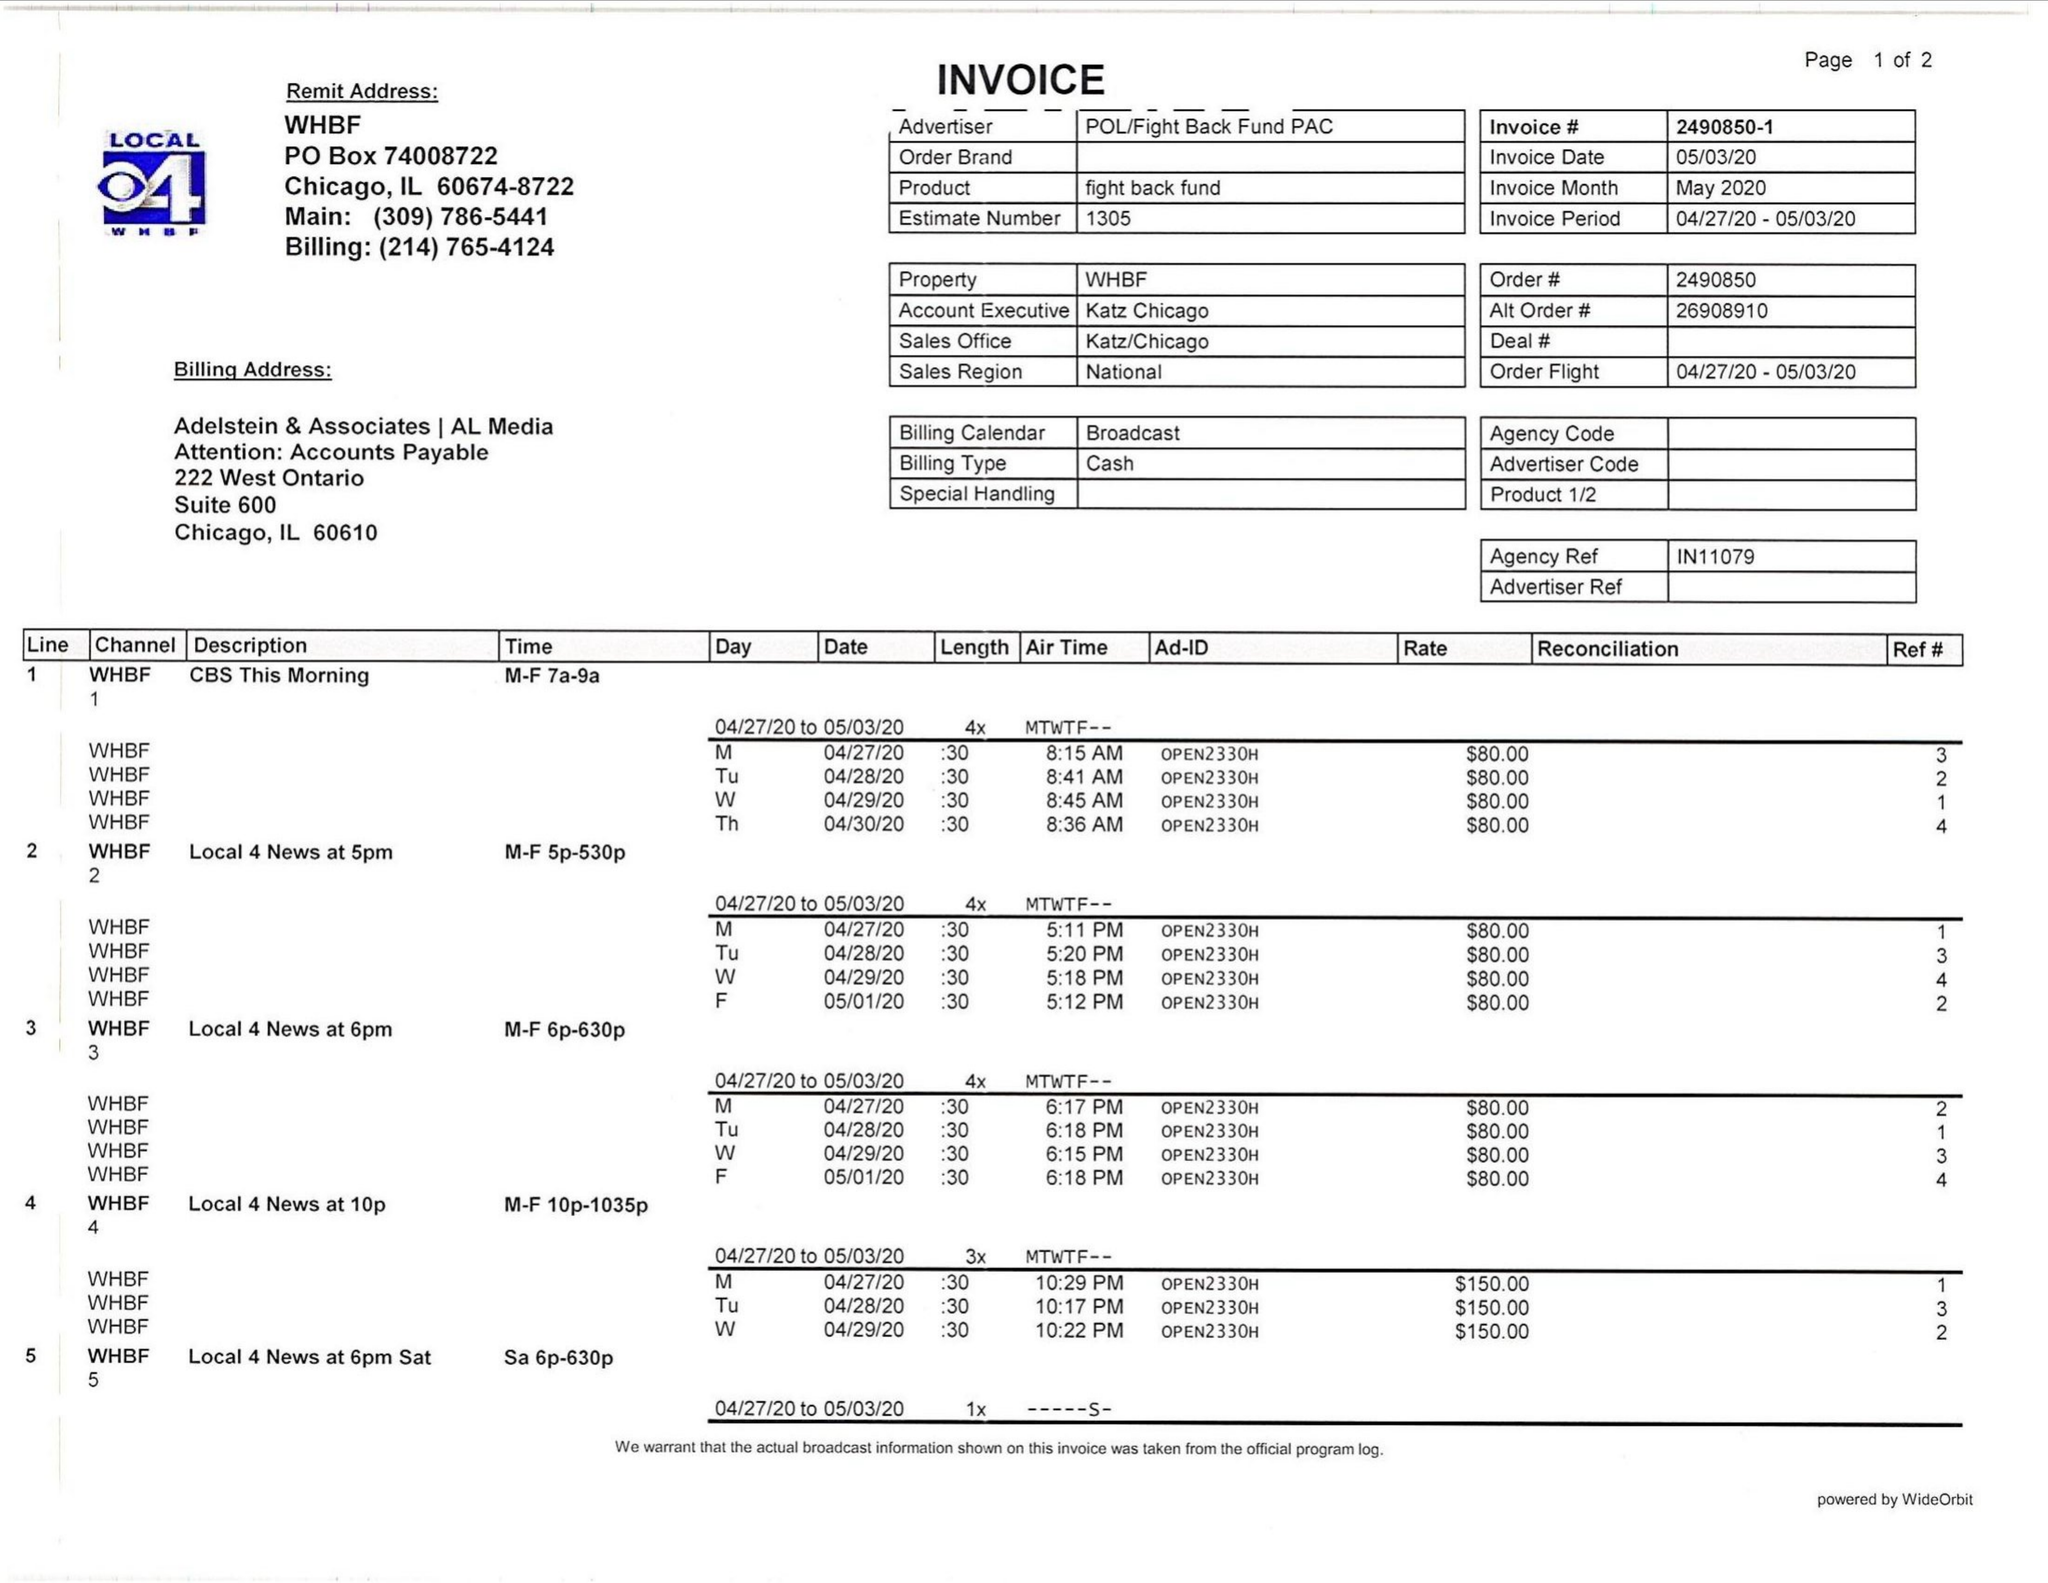What is the value for the advertiser?
Answer the question using a single word or phrase. POL/FIGHTBACKFUNDPAC 